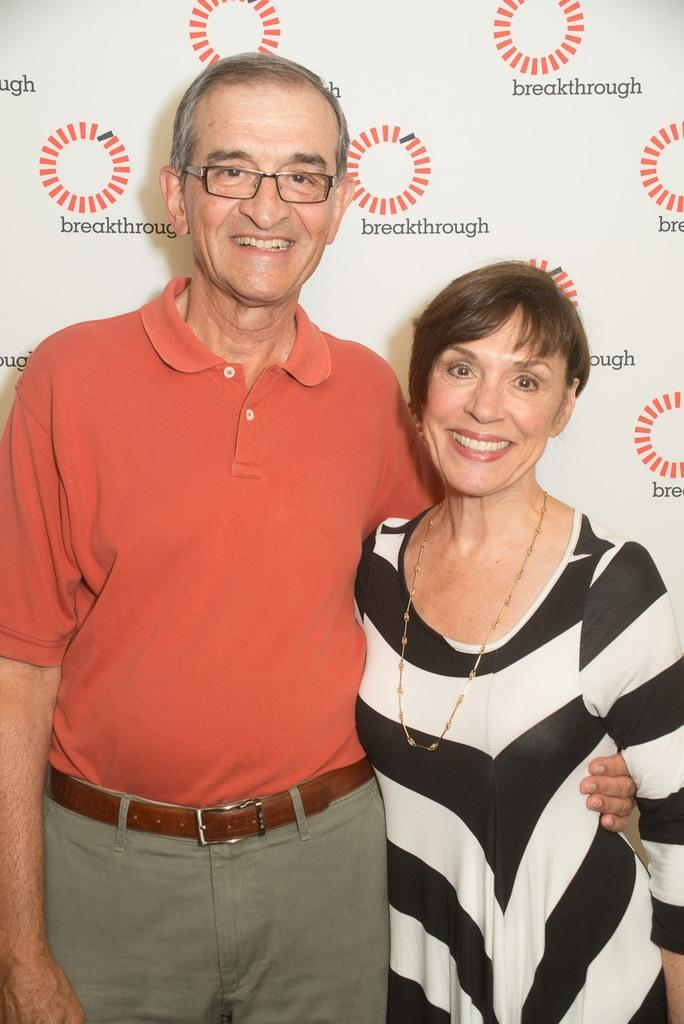How many people are present in the image? There are two people in the image, a man and a woman. What are the man and the woman doing in the image? Both the man and the woman are standing and smiling. What can be seen in the background of the image? There is a poster in the background of the image. Can you tell me how many friends are visible in the image? There is no mention of friends in the image, only a man and a woman. What time of day is it in the image, given that it is night? The provided facts do not mention the time of day, and there is no indication that it is night in the image. 